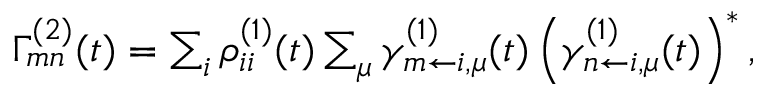<formula> <loc_0><loc_0><loc_500><loc_500>\begin{array} { r } { \Gamma _ { m n } ^ { ( 2 ) } ( t ) = \sum _ { i } \rho _ { i i } ^ { ( 1 ) } ( t ) \sum _ { \mu } \gamma _ { m \leftarrow i , \mu } ^ { ( 1 ) } ( t ) \left ( \gamma _ { n \leftarrow i , \mu } ^ { ( 1 ) } ( t ) \right ) ^ { \ast } , } \end{array}</formula> 